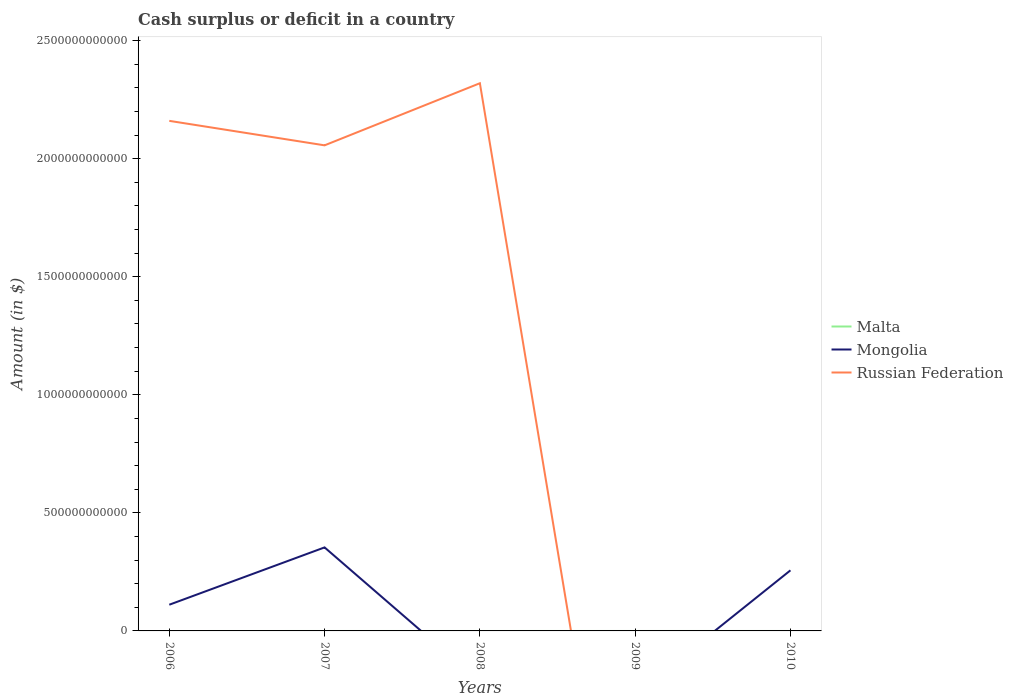Does the line corresponding to Russian Federation intersect with the line corresponding to Malta?
Ensure brevity in your answer.  Yes. Across all years, what is the maximum amount of cash surplus or deficit in Mongolia?
Keep it short and to the point. 0. What is the total amount of cash surplus or deficit in Russian Federation in the graph?
Your answer should be very brief. -1.59e+11. What is the difference between the highest and the second highest amount of cash surplus or deficit in Russian Federation?
Provide a short and direct response. 2.32e+12. What is the difference between the highest and the lowest amount of cash surplus or deficit in Mongolia?
Offer a terse response. 2. What is the difference between two consecutive major ticks on the Y-axis?
Provide a short and direct response. 5.00e+11. Does the graph contain grids?
Give a very brief answer. No. What is the title of the graph?
Make the answer very short. Cash surplus or deficit in a country. Does "Germany" appear as one of the legend labels in the graph?
Offer a very short reply. No. What is the label or title of the Y-axis?
Give a very brief answer. Amount (in $). What is the Amount (in $) in Malta in 2006?
Keep it short and to the point. 0. What is the Amount (in $) of Mongolia in 2006?
Your answer should be compact. 1.11e+11. What is the Amount (in $) in Russian Federation in 2006?
Your answer should be very brief. 2.16e+12. What is the Amount (in $) in Malta in 2007?
Ensure brevity in your answer.  0. What is the Amount (in $) in Mongolia in 2007?
Offer a terse response. 3.54e+11. What is the Amount (in $) in Russian Federation in 2007?
Provide a short and direct response. 2.06e+12. What is the Amount (in $) of Malta in 2008?
Offer a terse response. 0. What is the Amount (in $) in Mongolia in 2008?
Your answer should be very brief. 0. What is the Amount (in $) in Russian Federation in 2008?
Keep it short and to the point. 2.32e+12. What is the Amount (in $) in Mongolia in 2009?
Offer a terse response. 0. What is the Amount (in $) in Russian Federation in 2009?
Provide a short and direct response. 0. What is the Amount (in $) of Mongolia in 2010?
Your response must be concise. 2.57e+11. What is the Amount (in $) of Russian Federation in 2010?
Provide a short and direct response. 0. Across all years, what is the maximum Amount (in $) in Mongolia?
Keep it short and to the point. 3.54e+11. Across all years, what is the maximum Amount (in $) in Russian Federation?
Ensure brevity in your answer.  2.32e+12. What is the total Amount (in $) of Mongolia in the graph?
Keep it short and to the point. 7.21e+11. What is the total Amount (in $) in Russian Federation in the graph?
Offer a very short reply. 6.54e+12. What is the difference between the Amount (in $) in Mongolia in 2006 and that in 2007?
Keep it short and to the point. -2.43e+11. What is the difference between the Amount (in $) of Russian Federation in 2006 and that in 2007?
Provide a short and direct response. 1.04e+11. What is the difference between the Amount (in $) of Russian Federation in 2006 and that in 2008?
Offer a terse response. -1.59e+11. What is the difference between the Amount (in $) of Mongolia in 2006 and that in 2010?
Ensure brevity in your answer.  -1.46e+11. What is the difference between the Amount (in $) of Russian Federation in 2007 and that in 2008?
Your answer should be compact. -2.63e+11. What is the difference between the Amount (in $) of Mongolia in 2007 and that in 2010?
Give a very brief answer. 9.71e+1. What is the difference between the Amount (in $) in Mongolia in 2006 and the Amount (in $) in Russian Federation in 2007?
Offer a terse response. -1.95e+12. What is the difference between the Amount (in $) of Mongolia in 2006 and the Amount (in $) of Russian Federation in 2008?
Your answer should be compact. -2.21e+12. What is the difference between the Amount (in $) of Mongolia in 2007 and the Amount (in $) of Russian Federation in 2008?
Provide a succinct answer. -1.97e+12. What is the average Amount (in $) in Mongolia per year?
Your answer should be compact. 1.44e+11. What is the average Amount (in $) of Russian Federation per year?
Provide a succinct answer. 1.31e+12. In the year 2006, what is the difference between the Amount (in $) in Mongolia and Amount (in $) in Russian Federation?
Offer a terse response. -2.05e+12. In the year 2007, what is the difference between the Amount (in $) of Mongolia and Amount (in $) of Russian Federation?
Provide a short and direct response. -1.70e+12. What is the ratio of the Amount (in $) in Mongolia in 2006 to that in 2007?
Make the answer very short. 0.31. What is the ratio of the Amount (in $) of Russian Federation in 2006 to that in 2007?
Keep it short and to the point. 1.05. What is the ratio of the Amount (in $) in Russian Federation in 2006 to that in 2008?
Offer a terse response. 0.93. What is the ratio of the Amount (in $) of Mongolia in 2006 to that in 2010?
Give a very brief answer. 0.43. What is the ratio of the Amount (in $) in Russian Federation in 2007 to that in 2008?
Give a very brief answer. 0.89. What is the ratio of the Amount (in $) in Mongolia in 2007 to that in 2010?
Your response must be concise. 1.38. What is the difference between the highest and the second highest Amount (in $) in Mongolia?
Your response must be concise. 9.71e+1. What is the difference between the highest and the second highest Amount (in $) of Russian Federation?
Ensure brevity in your answer.  1.59e+11. What is the difference between the highest and the lowest Amount (in $) in Mongolia?
Provide a succinct answer. 3.54e+11. What is the difference between the highest and the lowest Amount (in $) of Russian Federation?
Keep it short and to the point. 2.32e+12. 